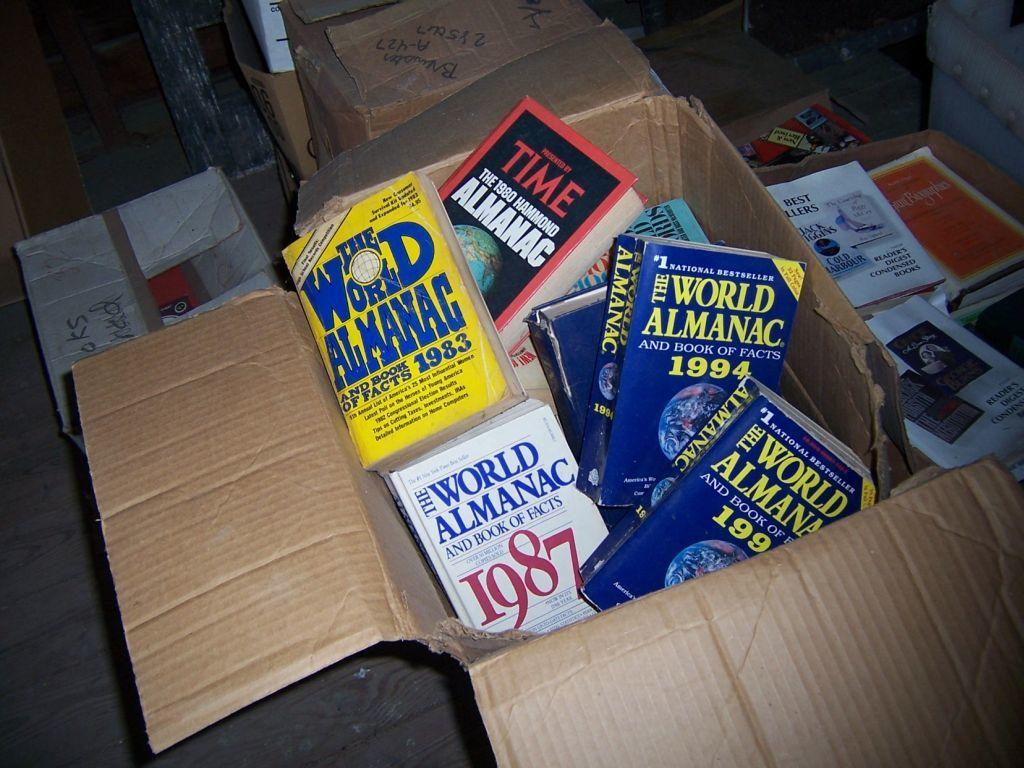<image>
Describe the image concisely. World amanac books inside of a cardboard box 